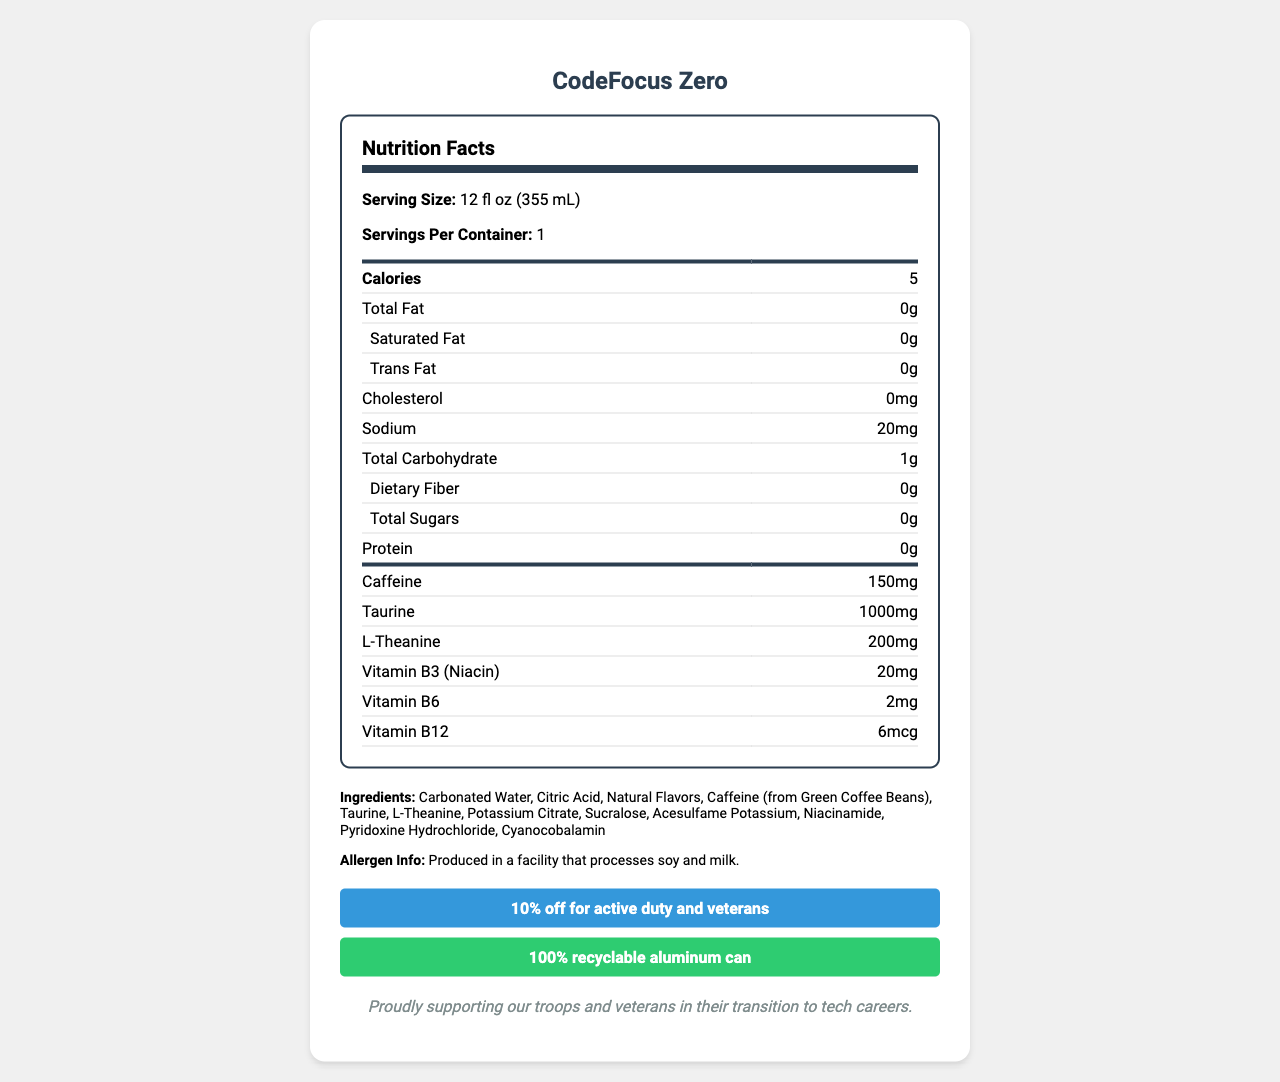What is the product name? The document header and main title clearly state the product name as "CodeFocus Zero".
Answer: CodeFocus Zero What is the serving size of CodeFocus Zero? The serving size is mentioned at the beginning of the Nutrition Facts section as 12 fl oz (355 mL).
Answer: 12 fl oz (355 mL) How much caffeine does one serving of CodeFocus Zero contain? Under the Nutrition Facts, "Caffeine" is listed as containing 150 mg per serving.
Answer: 150 mg What vitamins are included in CodeFocus Zero? The Nutrition Facts table lists the vitamins specifically as Vitamin B3 (Niacin), B6, and B12 with their respective quantities.
Answer: B3 (Niacin), B6, B12 What is the total carbohydrate content per serving? The total carbohydrate content is listed in the Nutrition Facts section as 1g per serving.
Answer: 1g Which of the following best describes the flavor profile of CodeFocus Zero? A. Tropical Blast B. Crisp Citrus Punch C. Berry Fusion D. Grape Splash The flavor profile is mentioned in the document as "Crisp Citrus Punch".
Answer: B. Crisp Citrus Punch What is the total sodium content in CodeFocus Zero? A. 10mg B. 20mg C. 50mg D. 100mg The sodium content is listed in the Nutrition Facts section as 20mg per serving.
Answer: B. 20mg How much taurine is in one serving? A. 500mg B. 800mg C. 1000mg D. 1500mg The taurine content per serving is listed as 1000mg in the Nutrition Facts.
Answer: C. 1000mg Is CodeFocus Zero suitable for someone following a keto diet? The health claims section lists the beverage as "Keto-friendly".
Answer: Yes Does the document specify if CodeFocus Zero is produced in a facility that processes any allergens? The document states "Produced in a facility that processes soy and milk" under allergen information.
Answer: Yes What special discount is available for military veterans? The document mentions a "10% off for active duty and veterans" discount in a dedicated section.
Answer: 10% off for active duty and veterans Describe the main features and nutritional profile of CodeFocus Zero. The explanation includes main features such as caffeine and taurine content, health claims, and special offers as presented in the document.
Answer: CodeFocus Zero is a caffeine-enhanced, sugar-free beverage designed to improve mental focus during coding sessions. It has 5 calories per serving and contains key ingredients such as caffeine (150mg), taurine (1000mg), and L-Theanine (200mg). The beverage is free of fat, cholesterol, and sugars and includes vitamins B3, B6, and B12. It is marketed as vegan, keto-friendly, and has eco-friendly packaging with a 10% discount for military veterans. What is the company's stated mission or ethos regarding veterans? The company's statement at the bottom of the document highlights their support for troops and veterans in their transition to tech careers.
Answer: Proudly supporting our troops and veterans in their transition to tech careers. Does CodeFocus Zero contain any Vitamin D? The document does not mention the presence of Vitamin D, neither in its Nutrition Facts nor in the ingredients.
Answer: Not enough information What might be the potential use case for CodeFocus Zero? The product is described as a caffeine-enhanced, sugar-free beverage designed to improve mental focus during coding sessions, indicating its use case for activities requiring focus, such as coding.
Answer: Improving mental focus during coding sessions How many grams of protein are there in CodeFocus Zero? The document under Nutrition Facts lists the protein content as 0g per serving.
Answer: 0g 